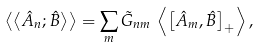<formula> <loc_0><loc_0><loc_500><loc_500>\left < \left < \hat { A } _ { n } ; \hat { B } \right > \right > = \sum _ { m } \tilde { G } _ { n m } \, \left < \left [ \hat { A } _ { m } , \hat { B } \right ] _ { + } \right > ,</formula> 